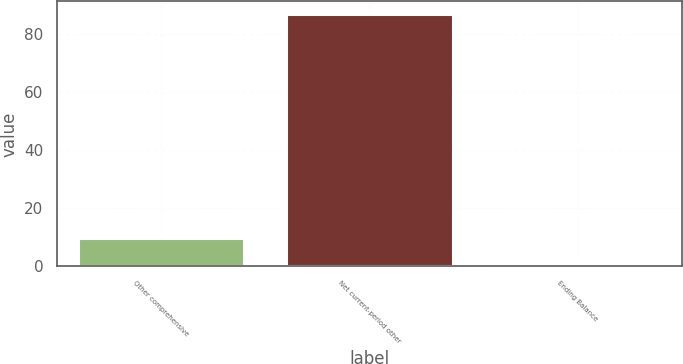Convert chart to OTSL. <chart><loc_0><loc_0><loc_500><loc_500><bar_chart><fcel>Other comprehensive<fcel>Net current-period other<fcel>Ending Balance<nl><fcel>9.6<fcel>87<fcel>1<nl></chart> 